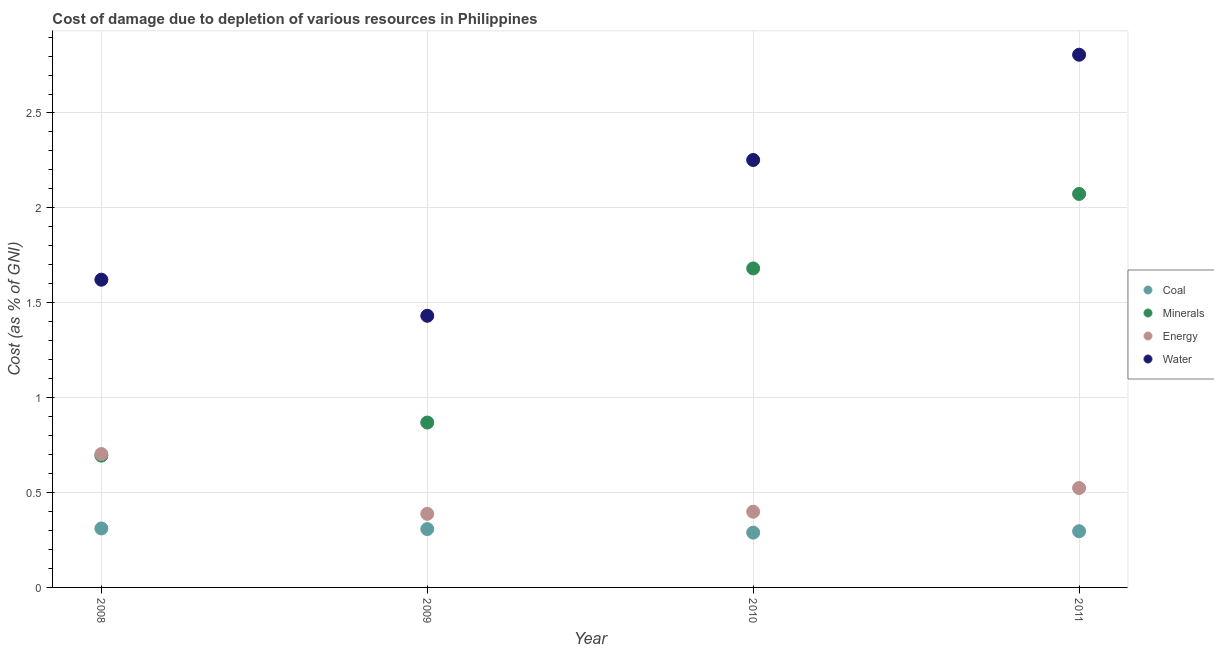How many different coloured dotlines are there?
Give a very brief answer. 4. What is the cost of damage due to depletion of water in 2008?
Offer a very short reply. 1.62. Across all years, what is the maximum cost of damage due to depletion of water?
Make the answer very short. 2.81. Across all years, what is the minimum cost of damage due to depletion of water?
Make the answer very short. 1.43. In which year was the cost of damage due to depletion of energy minimum?
Give a very brief answer. 2009. What is the total cost of damage due to depletion of energy in the graph?
Provide a short and direct response. 2.01. What is the difference between the cost of damage due to depletion of coal in 2008 and that in 2010?
Your response must be concise. 0.02. What is the difference between the cost of damage due to depletion of minerals in 2010 and the cost of damage due to depletion of energy in 2008?
Your answer should be very brief. 0.98. What is the average cost of damage due to depletion of minerals per year?
Provide a short and direct response. 1.33. In the year 2009, what is the difference between the cost of damage due to depletion of minerals and cost of damage due to depletion of coal?
Provide a short and direct response. 0.56. In how many years, is the cost of damage due to depletion of coal greater than 2.3 %?
Offer a very short reply. 0. What is the ratio of the cost of damage due to depletion of water in 2009 to that in 2010?
Ensure brevity in your answer.  0.64. Is the cost of damage due to depletion of minerals in 2008 less than that in 2009?
Offer a terse response. Yes. Is the difference between the cost of damage due to depletion of energy in 2008 and 2009 greater than the difference between the cost of damage due to depletion of minerals in 2008 and 2009?
Offer a very short reply. Yes. What is the difference between the highest and the second highest cost of damage due to depletion of energy?
Your answer should be very brief. 0.18. What is the difference between the highest and the lowest cost of damage due to depletion of energy?
Give a very brief answer. 0.32. Is the sum of the cost of damage due to depletion of water in 2008 and 2009 greater than the maximum cost of damage due to depletion of energy across all years?
Provide a succinct answer. Yes. Is it the case that in every year, the sum of the cost of damage due to depletion of minerals and cost of damage due to depletion of water is greater than the sum of cost of damage due to depletion of coal and cost of damage due to depletion of energy?
Give a very brief answer. Yes. Is it the case that in every year, the sum of the cost of damage due to depletion of coal and cost of damage due to depletion of minerals is greater than the cost of damage due to depletion of energy?
Keep it short and to the point. Yes. Is the cost of damage due to depletion of minerals strictly greater than the cost of damage due to depletion of water over the years?
Make the answer very short. No. Is the cost of damage due to depletion of water strictly less than the cost of damage due to depletion of energy over the years?
Your answer should be very brief. No. How many dotlines are there?
Provide a short and direct response. 4. What is the difference between two consecutive major ticks on the Y-axis?
Give a very brief answer. 0.5. Are the values on the major ticks of Y-axis written in scientific E-notation?
Your answer should be very brief. No. Does the graph contain any zero values?
Keep it short and to the point. No. Does the graph contain grids?
Ensure brevity in your answer.  Yes. How many legend labels are there?
Make the answer very short. 4. How are the legend labels stacked?
Provide a succinct answer. Vertical. What is the title of the graph?
Make the answer very short. Cost of damage due to depletion of various resources in Philippines . What is the label or title of the X-axis?
Your response must be concise. Year. What is the label or title of the Y-axis?
Offer a terse response. Cost (as % of GNI). What is the Cost (as % of GNI) of Coal in 2008?
Provide a succinct answer. 0.31. What is the Cost (as % of GNI) of Minerals in 2008?
Offer a very short reply. 0.69. What is the Cost (as % of GNI) of Energy in 2008?
Offer a terse response. 0.7. What is the Cost (as % of GNI) of Water in 2008?
Give a very brief answer. 1.62. What is the Cost (as % of GNI) in Coal in 2009?
Offer a very short reply. 0.31. What is the Cost (as % of GNI) in Minerals in 2009?
Keep it short and to the point. 0.87. What is the Cost (as % of GNI) of Energy in 2009?
Your answer should be compact. 0.39. What is the Cost (as % of GNI) of Water in 2009?
Your answer should be compact. 1.43. What is the Cost (as % of GNI) of Coal in 2010?
Your response must be concise. 0.29. What is the Cost (as % of GNI) in Minerals in 2010?
Your answer should be compact. 1.68. What is the Cost (as % of GNI) in Energy in 2010?
Offer a very short reply. 0.4. What is the Cost (as % of GNI) in Water in 2010?
Offer a terse response. 2.25. What is the Cost (as % of GNI) in Coal in 2011?
Ensure brevity in your answer.  0.3. What is the Cost (as % of GNI) of Minerals in 2011?
Provide a succinct answer. 2.07. What is the Cost (as % of GNI) in Energy in 2011?
Make the answer very short. 0.52. What is the Cost (as % of GNI) of Water in 2011?
Make the answer very short. 2.81. Across all years, what is the maximum Cost (as % of GNI) of Coal?
Make the answer very short. 0.31. Across all years, what is the maximum Cost (as % of GNI) in Minerals?
Provide a short and direct response. 2.07. Across all years, what is the maximum Cost (as % of GNI) in Energy?
Provide a short and direct response. 0.7. Across all years, what is the maximum Cost (as % of GNI) of Water?
Your response must be concise. 2.81. Across all years, what is the minimum Cost (as % of GNI) in Coal?
Keep it short and to the point. 0.29. Across all years, what is the minimum Cost (as % of GNI) in Minerals?
Your response must be concise. 0.69. Across all years, what is the minimum Cost (as % of GNI) in Energy?
Offer a terse response. 0.39. Across all years, what is the minimum Cost (as % of GNI) in Water?
Your answer should be compact. 1.43. What is the total Cost (as % of GNI) of Coal in the graph?
Your answer should be very brief. 1.2. What is the total Cost (as % of GNI) in Minerals in the graph?
Your answer should be compact. 5.32. What is the total Cost (as % of GNI) of Energy in the graph?
Give a very brief answer. 2.01. What is the total Cost (as % of GNI) in Water in the graph?
Offer a terse response. 8.11. What is the difference between the Cost (as % of GNI) in Coal in 2008 and that in 2009?
Your answer should be compact. 0. What is the difference between the Cost (as % of GNI) of Minerals in 2008 and that in 2009?
Give a very brief answer. -0.17. What is the difference between the Cost (as % of GNI) of Energy in 2008 and that in 2009?
Give a very brief answer. 0.32. What is the difference between the Cost (as % of GNI) of Water in 2008 and that in 2009?
Your answer should be very brief. 0.19. What is the difference between the Cost (as % of GNI) of Coal in 2008 and that in 2010?
Provide a short and direct response. 0.02. What is the difference between the Cost (as % of GNI) of Minerals in 2008 and that in 2010?
Your answer should be very brief. -0.99. What is the difference between the Cost (as % of GNI) of Energy in 2008 and that in 2010?
Give a very brief answer. 0.3. What is the difference between the Cost (as % of GNI) of Water in 2008 and that in 2010?
Give a very brief answer. -0.63. What is the difference between the Cost (as % of GNI) of Coal in 2008 and that in 2011?
Ensure brevity in your answer.  0.01. What is the difference between the Cost (as % of GNI) in Minerals in 2008 and that in 2011?
Give a very brief answer. -1.38. What is the difference between the Cost (as % of GNI) of Energy in 2008 and that in 2011?
Your response must be concise. 0.18. What is the difference between the Cost (as % of GNI) of Water in 2008 and that in 2011?
Your answer should be very brief. -1.19. What is the difference between the Cost (as % of GNI) in Coal in 2009 and that in 2010?
Provide a succinct answer. 0.02. What is the difference between the Cost (as % of GNI) of Minerals in 2009 and that in 2010?
Your answer should be very brief. -0.81. What is the difference between the Cost (as % of GNI) in Energy in 2009 and that in 2010?
Offer a very short reply. -0.01. What is the difference between the Cost (as % of GNI) of Water in 2009 and that in 2010?
Ensure brevity in your answer.  -0.82. What is the difference between the Cost (as % of GNI) in Coal in 2009 and that in 2011?
Provide a short and direct response. 0.01. What is the difference between the Cost (as % of GNI) in Minerals in 2009 and that in 2011?
Offer a very short reply. -1.2. What is the difference between the Cost (as % of GNI) of Energy in 2009 and that in 2011?
Give a very brief answer. -0.14. What is the difference between the Cost (as % of GNI) in Water in 2009 and that in 2011?
Keep it short and to the point. -1.38. What is the difference between the Cost (as % of GNI) in Coal in 2010 and that in 2011?
Ensure brevity in your answer.  -0.01. What is the difference between the Cost (as % of GNI) in Minerals in 2010 and that in 2011?
Offer a very short reply. -0.39. What is the difference between the Cost (as % of GNI) of Energy in 2010 and that in 2011?
Ensure brevity in your answer.  -0.12. What is the difference between the Cost (as % of GNI) in Water in 2010 and that in 2011?
Make the answer very short. -0.55. What is the difference between the Cost (as % of GNI) of Coal in 2008 and the Cost (as % of GNI) of Minerals in 2009?
Offer a terse response. -0.56. What is the difference between the Cost (as % of GNI) of Coal in 2008 and the Cost (as % of GNI) of Energy in 2009?
Offer a terse response. -0.08. What is the difference between the Cost (as % of GNI) of Coal in 2008 and the Cost (as % of GNI) of Water in 2009?
Keep it short and to the point. -1.12. What is the difference between the Cost (as % of GNI) of Minerals in 2008 and the Cost (as % of GNI) of Energy in 2009?
Ensure brevity in your answer.  0.31. What is the difference between the Cost (as % of GNI) of Minerals in 2008 and the Cost (as % of GNI) of Water in 2009?
Give a very brief answer. -0.74. What is the difference between the Cost (as % of GNI) of Energy in 2008 and the Cost (as % of GNI) of Water in 2009?
Your response must be concise. -0.73. What is the difference between the Cost (as % of GNI) in Coal in 2008 and the Cost (as % of GNI) in Minerals in 2010?
Offer a terse response. -1.37. What is the difference between the Cost (as % of GNI) of Coal in 2008 and the Cost (as % of GNI) of Energy in 2010?
Ensure brevity in your answer.  -0.09. What is the difference between the Cost (as % of GNI) in Coal in 2008 and the Cost (as % of GNI) in Water in 2010?
Offer a very short reply. -1.94. What is the difference between the Cost (as % of GNI) of Minerals in 2008 and the Cost (as % of GNI) of Energy in 2010?
Your answer should be very brief. 0.3. What is the difference between the Cost (as % of GNI) in Minerals in 2008 and the Cost (as % of GNI) in Water in 2010?
Make the answer very short. -1.56. What is the difference between the Cost (as % of GNI) in Energy in 2008 and the Cost (as % of GNI) in Water in 2010?
Your answer should be compact. -1.55. What is the difference between the Cost (as % of GNI) in Coal in 2008 and the Cost (as % of GNI) in Minerals in 2011?
Your response must be concise. -1.76. What is the difference between the Cost (as % of GNI) of Coal in 2008 and the Cost (as % of GNI) of Energy in 2011?
Offer a very short reply. -0.21. What is the difference between the Cost (as % of GNI) of Coal in 2008 and the Cost (as % of GNI) of Water in 2011?
Give a very brief answer. -2.5. What is the difference between the Cost (as % of GNI) of Minerals in 2008 and the Cost (as % of GNI) of Energy in 2011?
Your answer should be very brief. 0.17. What is the difference between the Cost (as % of GNI) of Minerals in 2008 and the Cost (as % of GNI) of Water in 2011?
Offer a very short reply. -2.11. What is the difference between the Cost (as % of GNI) in Energy in 2008 and the Cost (as % of GNI) in Water in 2011?
Give a very brief answer. -2.1. What is the difference between the Cost (as % of GNI) of Coal in 2009 and the Cost (as % of GNI) of Minerals in 2010?
Make the answer very short. -1.37. What is the difference between the Cost (as % of GNI) in Coal in 2009 and the Cost (as % of GNI) in Energy in 2010?
Offer a very short reply. -0.09. What is the difference between the Cost (as % of GNI) of Coal in 2009 and the Cost (as % of GNI) of Water in 2010?
Your answer should be compact. -1.94. What is the difference between the Cost (as % of GNI) of Minerals in 2009 and the Cost (as % of GNI) of Energy in 2010?
Ensure brevity in your answer.  0.47. What is the difference between the Cost (as % of GNI) of Minerals in 2009 and the Cost (as % of GNI) of Water in 2010?
Provide a short and direct response. -1.38. What is the difference between the Cost (as % of GNI) in Energy in 2009 and the Cost (as % of GNI) in Water in 2010?
Keep it short and to the point. -1.86. What is the difference between the Cost (as % of GNI) in Coal in 2009 and the Cost (as % of GNI) in Minerals in 2011?
Provide a short and direct response. -1.77. What is the difference between the Cost (as % of GNI) in Coal in 2009 and the Cost (as % of GNI) in Energy in 2011?
Offer a very short reply. -0.22. What is the difference between the Cost (as % of GNI) of Coal in 2009 and the Cost (as % of GNI) of Water in 2011?
Provide a succinct answer. -2.5. What is the difference between the Cost (as % of GNI) of Minerals in 2009 and the Cost (as % of GNI) of Energy in 2011?
Your answer should be very brief. 0.35. What is the difference between the Cost (as % of GNI) of Minerals in 2009 and the Cost (as % of GNI) of Water in 2011?
Make the answer very short. -1.94. What is the difference between the Cost (as % of GNI) in Energy in 2009 and the Cost (as % of GNI) in Water in 2011?
Give a very brief answer. -2.42. What is the difference between the Cost (as % of GNI) in Coal in 2010 and the Cost (as % of GNI) in Minerals in 2011?
Your response must be concise. -1.78. What is the difference between the Cost (as % of GNI) of Coal in 2010 and the Cost (as % of GNI) of Energy in 2011?
Give a very brief answer. -0.23. What is the difference between the Cost (as % of GNI) of Coal in 2010 and the Cost (as % of GNI) of Water in 2011?
Provide a succinct answer. -2.52. What is the difference between the Cost (as % of GNI) in Minerals in 2010 and the Cost (as % of GNI) in Energy in 2011?
Offer a terse response. 1.16. What is the difference between the Cost (as % of GNI) of Minerals in 2010 and the Cost (as % of GNI) of Water in 2011?
Your answer should be compact. -1.13. What is the difference between the Cost (as % of GNI) in Energy in 2010 and the Cost (as % of GNI) in Water in 2011?
Offer a terse response. -2.41. What is the average Cost (as % of GNI) of Coal per year?
Your answer should be compact. 0.3. What is the average Cost (as % of GNI) of Minerals per year?
Your answer should be very brief. 1.33. What is the average Cost (as % of GNI) of Energy per year?
Keep it short and to the point. 0.5. What is the average Cost (as % of GNI) in Water per year?
Provide a short and direct response. 2.03. In the year 2008, what is the difference between the Cost (as % of GNI) of Coal and Cost (as % of GNI) of Minerals?
Offer a terse response. -0.38. In the year 2008, what is the difference between the Cost (as % of GNI) in Coal and Cost (as % of GNI) in Energy?
Offer a very short reply. -0.39. In the year 2008, what is the difference between the Cost (as % of GNI) in Coal and Cost (as % of GNI) in Water?
Offer a terse response. -1.31. In the year 2008, what is the difference between the Cost (as % of GNI) in Minerals and Cost (as % of GNI) in Energy?
Keep it short and to the point. -0.01. In the year 2008, what is the difference between the Cost (as % of GNI) in Minerals and Cost (as % of GNI) in Water?
Your answer should be compact. -0.93. In the year 2008, what is the difference between the Cost (as % of GNI) of Energy and Cost (as % of GNI) of Water?
Offer a terse response. -0.92. In the year 2009, what is the difference between the Cost (as % of GNI) of Coal and Cost (as % of GNI) of Minerals?
Ensure brevity in your answer.  -0.56. In the year 2009, what is the difference between the Cost (as % of GNI) of Coal and Cost (as % of GNI) of Energy?
Your answer should be very brief. -0.08. In the year 2009, what is the difference between the Cost (as % of GNI) in Coal and Cost (as % of GNI) in Water?
Provide a short and direct response. -1.12. In the year 2009, what is the difference between the Cost (as % of GNI) in Minerals and Cost (as % of GNI) in Energy?
Offer a very short reply. 0.48. In the year 2009, what is the difference between the Cost (as % of GNI) of Minerals and Cost (as % of GNI) of Water?
Offer a very short reply. -0.56. In the year 2009, what is the difference between the Cost (as % of GNI) in Energy and Cost (as % of GNI) in Water?
Give a very brief answer. -1.04. In the year 2010, what is the difference between the Cost (as % of GNI) in Coal and Cost (as % of GNI) in Minerals?
Your answer should be very brief. -1.39. In the year 2010, what is the difference between the Cost (as % of GNI) in Coal and Cost (as % of GNI) in Energy?
Give a very brief answer. -0.11. In the year 2010, what is the difference between the Cost (as % of GNI) in Coal and Cost (as % of GNI) in Water?
Your answer should be compact. -1.96. In the year 2010, what is the difference between the Cost (as % of GNI) of Minerals and Cost (as % of GNI) of Energy?
Your response must be concise. 1.28. In the year 2010, what is the difference between the Cost (as % of GNI) in Minerals and Cost (as % of GNI) in Water?
Give a very brief answer. -0.57. In the year 2010, what is the difference between the Cost (as % of GNI) of Energy and Cost (as % of GNI) of Water?
Offer a terse response. -1.85. In the year 2011, what is the difference between the Cost (as % of GNI) in Coal and Cost (as % of GNI) in Minerals?
Your answer should be very brief. -1.78. In the year 2011, what is the difference between the Cost (as % of GNI) in Coal and Cost (as % of GNI) in Energy?
Your answer should be very brief. -0.23. In the year 2011, what is the difference between the Cost (as % of GNI) in Coal and Cost (as % of GNI) in Water?
Provide a succinct answer. -2.51. In the year 2011, what is the difference between the Cost (as % of GNI) of Minerals and Cost (as % of GNI) of Energy?
Provide a succinct answer. 1.55. In the year 2011, what is the difference between the Cost (as % of GNI) in Minerals and Cost (as % of GNI) in Water?
Provide a succinct answer. -0.73. In the year 2011, what is the difference between the Cost (as % of GNI) in Energy and Cost (as % of GNI) in Water?
Provide a short and direct response. -2.28. What is the ratio of the Cost (as % of GNI) in Coal in 2008 to that in 2009?
Provide a short and direct response. 1.01. What is the ratio of the Cost (as % of GNI) in Minerals in 2008 to that in 2009?
Provide a succinct answer. 0.8. What is the ratio of the Cost (as % of GNI) in Energy in 2008 to that in 2009?
Make the answer very short. 1.81. What is the ratio of the Cost (as % of GNI) of Water in 2008 to that in 2009?
Your response must be concise. 1.13. What is the ratio of the Cost (as % of GNI) in Coal in 2008 to that in 2010?
Ensure brevity in your answer.  1.08. What is the ratio of the Cost (as % of GNI) of Minerals in 2008 to that in 2010?
Your answer should be compact. 0.41. What is the ratio of the Cost (as % of GNI) in Energy in 2008 to that in 2010?
Give a very brief answer. 1.76. What is the ratio of the Cost (as % of GNI) of Water in 2008 to that in 2010?
Keep it short and to the point. 0.72. What is the ratio of the Cost (as % of GNI) of Coal in 2008 to that in 2011?
Offer a very short reply. 1.05. What is the ratio of the Cost (as % of GNI) in Minerals in 2008 to that in 2011?
Provide a succinct answer. 0.34. What is the ratio of the Cost (as % of GNI) of Energy in 2008 to that in 2011?
Give a very brief answer. 1.34. What is the ratio of the Cost (as % of GNI) in Water in 2008 to that in 2011?
Keep it short and to the point. 0.58. What is the ratio of the Cost (as % of GNI) in Coal in 2009 to that in 2010?
Provide a short and direct response. 1.07. What is the ratio of the Cost (as % of GNI) of Minerals in 2009 to that in 2010?
Give a very brief answer. 0.52. What is the ratio of the Cost (as % of GNI) in Water in 2009 to that in 2010?
Your response must be concise. 0.64. What is the ratio of the Cost (as % of GNI) in Coal in 2009 to that in 2011?
Your answer should be compact. 1.04. What is the ratio of the Cost (as % of GNI) of Minerals in 2009 to that in 2011?
Your response must be concise. 0.42. What is the ratio of the Cost (as % of GNI) in Energy in 2009 to that in 2011?
Your answer should be very brief. 0.74. What is the ratio of the Cost (as % of GNI) of Water in 2009 to that in 2011?
Provide a short and direct response. 0.51. What is the ratio of the Cost (as % of GNI) of Coal in 2010 to that in 2011?
Your answer should be compact. 0.98. What is the ratio of the Cost (as % of GNI) of Minerals in 2010 to that in 2011?
Your response must be concise. 0.81. What is the ratio of the Cost (as % of GNI) in Energy in 2010 to that in 2011?
Provide a succinct answer. 0.76. What is the ratio of the Cost (as % of GNI) in Water in 2010 to that in 2011?
Offer a terse response. 0.8. What is the difference between the highest and the second highest Cost (as % of GNI) in Coal?
Offer a very short reply. 0. What is the difference between the highest and the second highest Cost (as % of GNI) in Minerals?
Your answer should be very brief. 0.39. What is the difference between the highest and the second highest Cost (as % of GNI) of Energy?
Your answer should be very brief. 0.18. What is the difference between the highest and the second highest Cost (as % of GNI) of Water?
Your answer should be very brief. 0.55. What is the difference between the highest and the lowest Cost (as % of GNI) in Coal?
Provide a short and direct response. 0.02. What is the difference between the highest and the lowest Cost (as % of GNI) of Minerals?
Provide a succinct answer. 1.38. What is the difference between the highest and the lowest Cost (as % of GNI) in Energy?
Offer a terse response. 0.32. What is the difference between the highest and the lowest Cost (as % of GNI) in Water?
Provide a short and direct response. 1.38. 